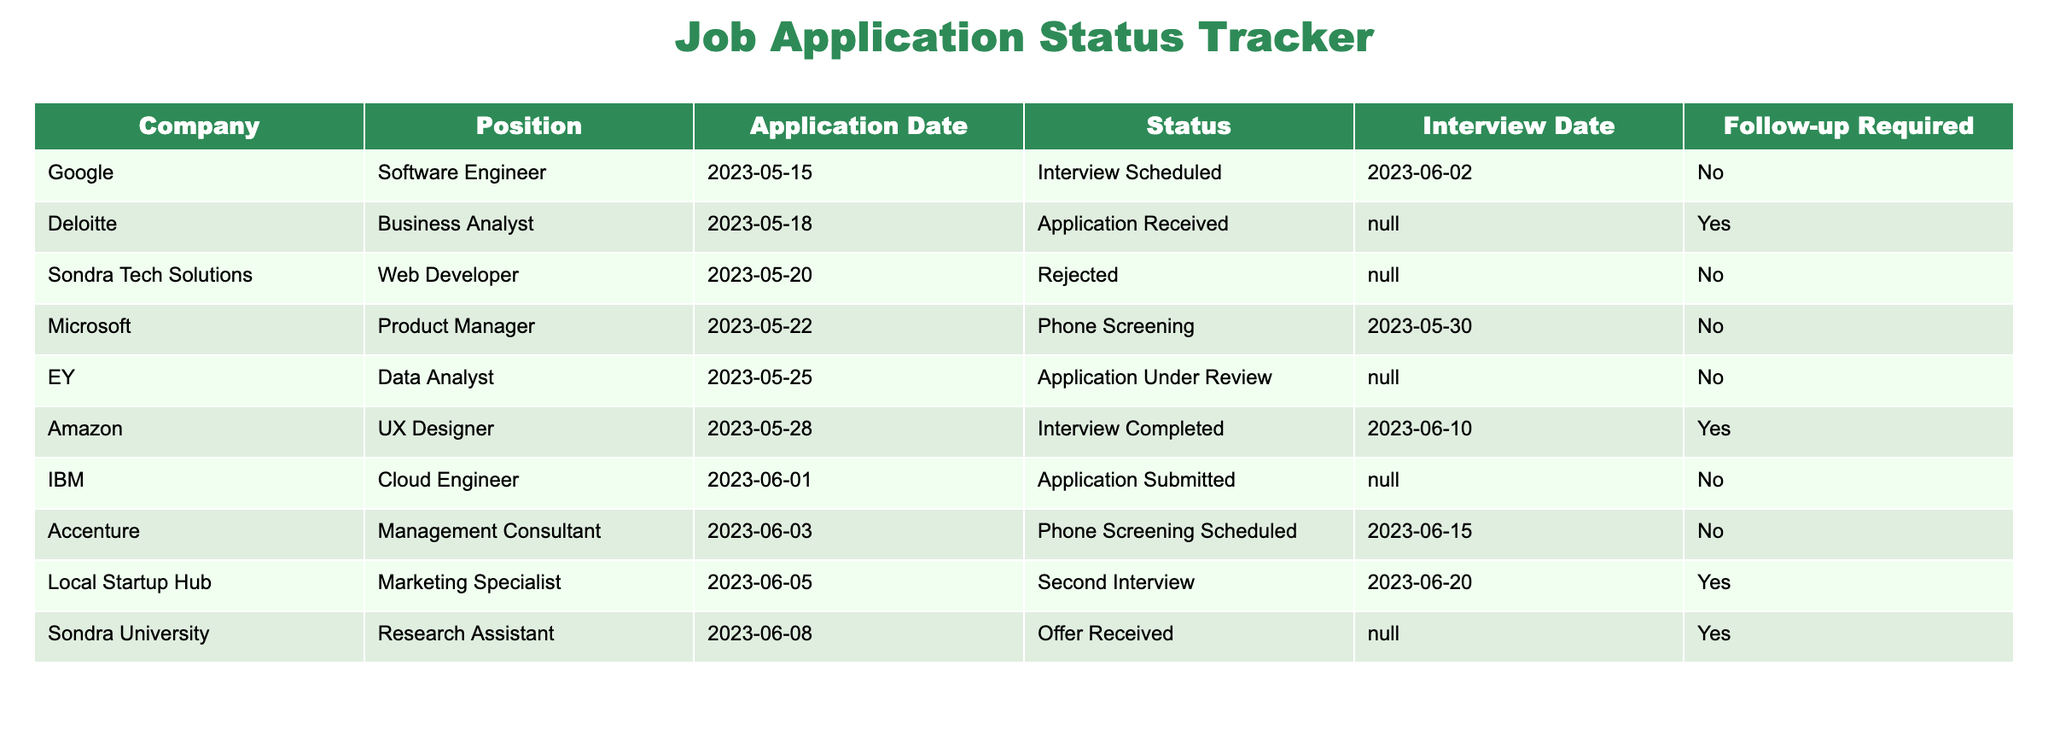What is the application status for the position at Google? The status for the position at Google (Software Engineer) is listed as "Interview Scheduled." This information can be found directly in the second column of the table next to the company name Google.
Answer: Interview Scheduled How many positions have a follow-up required? The table shows that the positions with a follow-up required are Business Analyst, UX Designer, and Marketing Specialist. Counting these listings gives a total of three positions that require follow-up.
Answer: 3 Did Sondra University extend an offer for the Research Assistant position? Yes, the status for the Research Assistant position at Sondra University is "Offer Received," which indicates that they extended an offer. This can be directly observed in the fourth column of the corresponding row.
Answer: Yes What is the time gap between the application date and interview date for the position at Amazon? The application date for the Amazon UX Designer position is 2023-05-28 and the interview date is 2023-06-10. To find the time gap, subtract the application date from the interview date, resulting in 13 days gap.
Answer: 13 days Which company has the earliest application date among the listed positions? By inspecting the application dates for each company, we see that Google has the earliest application date, which is 2023-05-15, as it is earlier than all other application dates in the table.
Answer: Google If a follow-up is required for a position, what is the maximum number of days before the interview date? For the positions requiring follow-up (Business Analyst, UX Designer, and Marketing Specialist), we note that the Business Analyst has no interview date, the UX Designer's interview is on 2023-06-10, and the Marketing Specialist's interview is on 2023-06-20. The maximum number of days to wait before its interview is 10 days (from 2023-06-10 to 2023-06-20).
Answer: 10 days How many applications are currently under review? The status for EY (Data Analyst) is "Application Under Review." Checking the table, this is the only application listed with this status, indicating there is one application currently under review.
Answer: 1 Are there any positions that have already completed interviews? Yes, the table shows that the position at Amazon (UX Designer) has the status "Interview Completed," which confirms that an interview has already taken place for this position.
Answer: Yes Which companies scheduled phone screenings? The companies that scheduled phone screenings are Microsoft (Product Manager) and Accenture (Management Consultant). These listings are directly available under the Status column (showing "Phone Screening" and "Phone Screening Scheduled").
Answer: Microsoft, Accenture What is the total number of companies listed in the application tracker? By counting the rows in the table, there are a total of 8 different companies listed in the job application status tracker. Each row corresponds to a different company in the table.
Answer: 8 